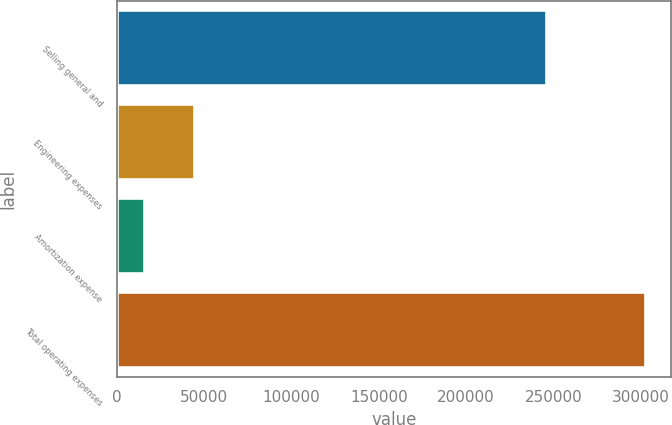Convert chart. <chart><loc_0><loc_0><loc_500><loc_500><bar_chart><fcel>Selling general and<fcel>Engineering expenses<fcel>Amortization expense<fcel>Total operating expenses<nl><fcel>245709<fcel>43973.6<fcel>15272<fcel>302288<nl></chart> 